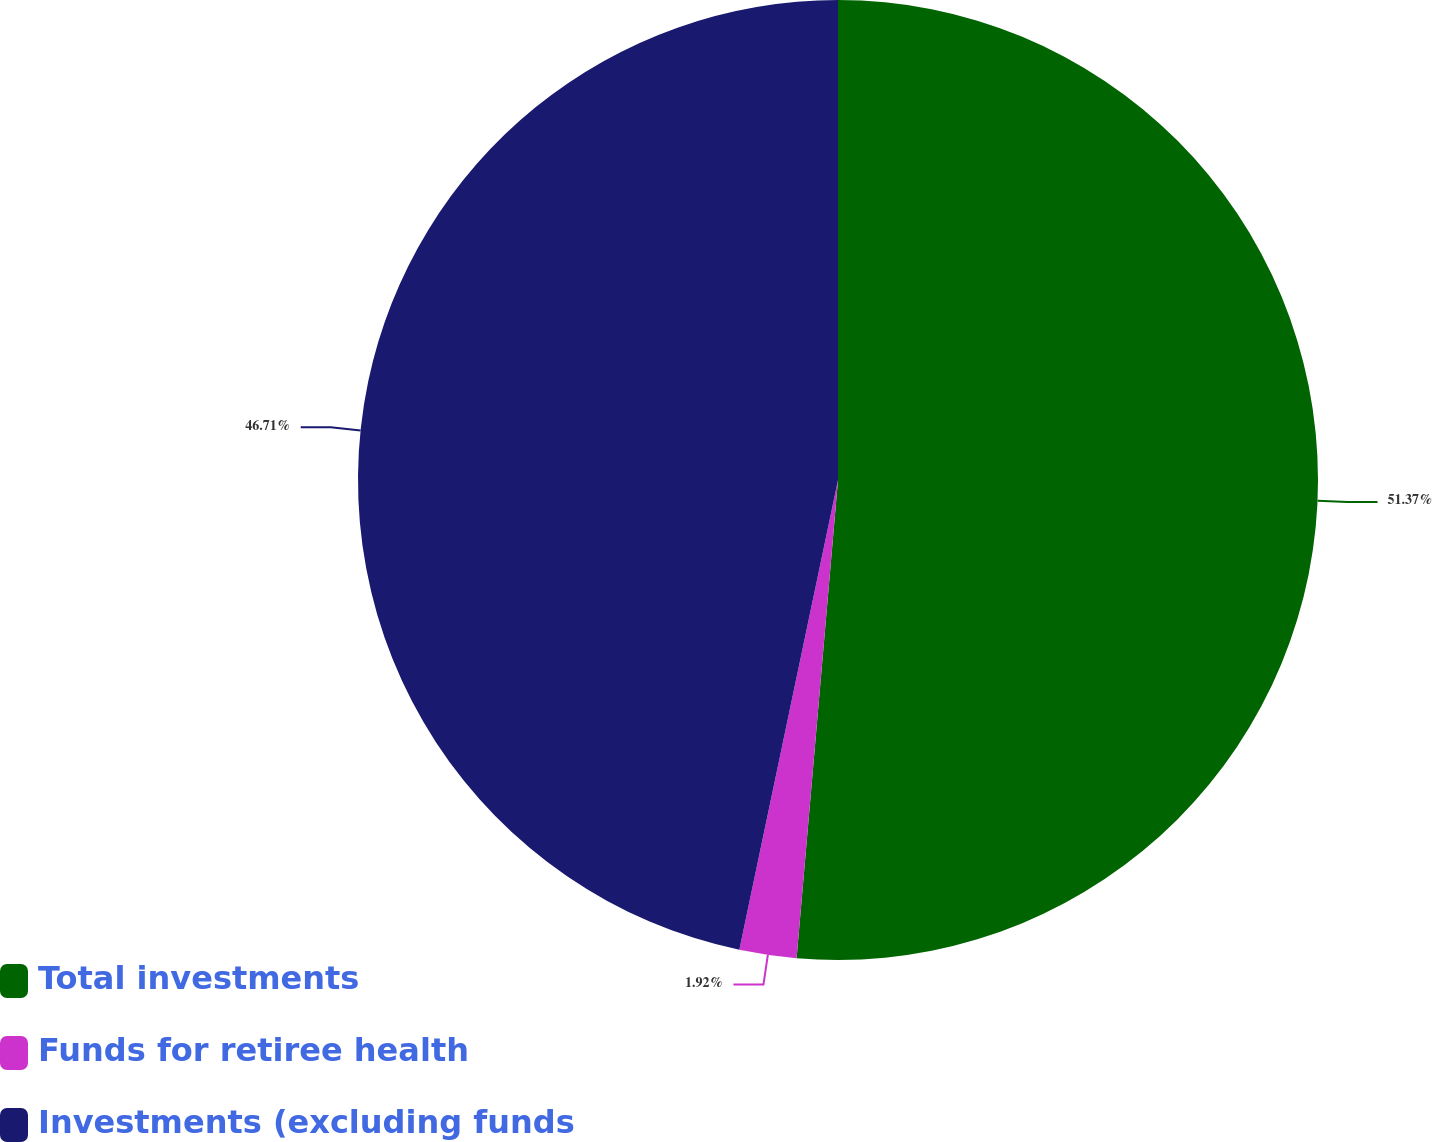Convert chart. <chart><loc_0><loc_0><loc_500><loc_500><pie_chart><fcel>Total investments<fcel>Funds for retiree health<fcel>Investments (excluding funds<nl><fcel>51.38%<fcel>1.92%<fcel>46.71%<nl></chart> 